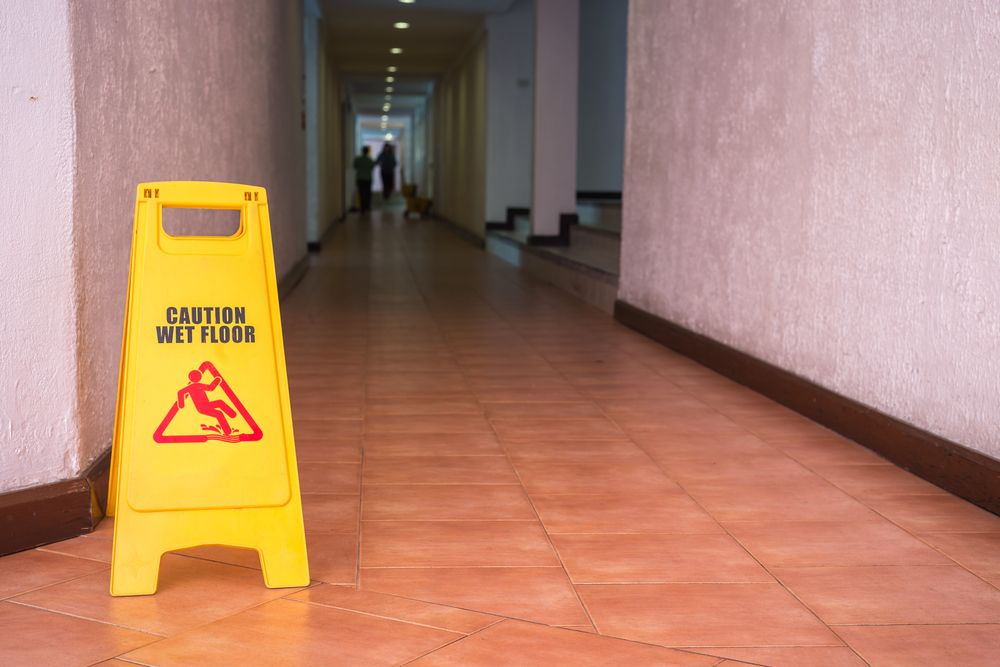Based on the image, what can be inferred about the maintenance practices in this building, particularly in relation to addressing potential safety hazards? From the image, it can be inferred that the building's maintenance team is diligent in addressing potential safety hazards. The presence of a conspicuous caution sign indicating a wet floor highlights a proactive approach to preventing accidents and ensuring the safety of individuals within the space. Furthermore, the corridor appears clean and well-lit, indicative of regular maintenance and a commitment to a clean and safe environment. These details combined suggest a well-maintained building with established safety protocols. 